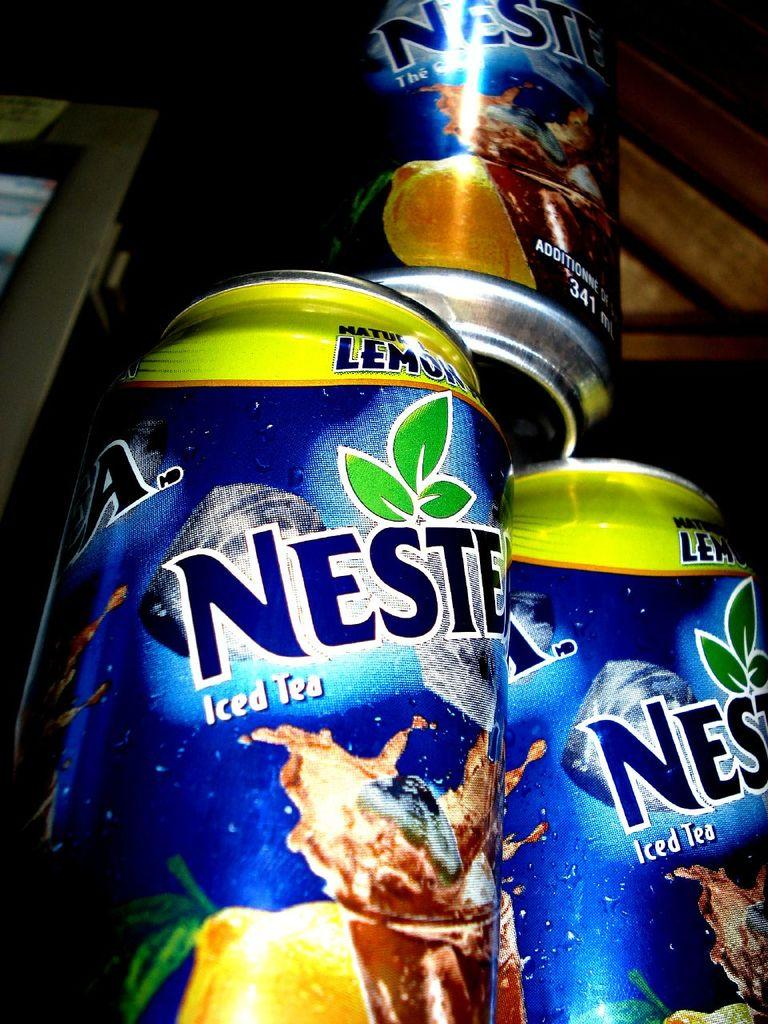<image>
Give a short and clear explanation of the subsequent image. Cans of Nestee brand iced tea sit in a pyramid. 